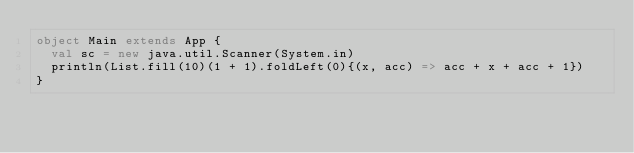<code> <loc_0><loc_0><loc_500><loc_500><_Scala_>object Main extends App {
  val sc = new java.util.Scanner(System.in)
  println(List.fill(10)(1 + 1).foldLeft(0){(x, acc) => acc + x + acc + 1})
}
</code> 